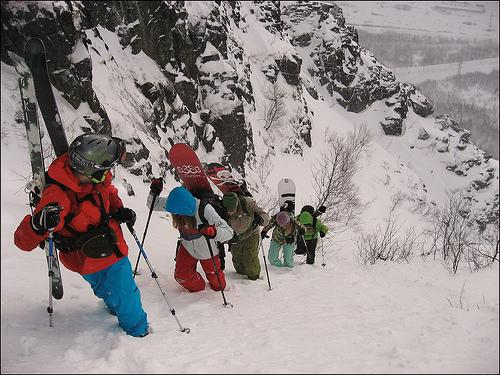Question: why are the wearing gear?
Choices:
A. Protect from injury.
B. Fashion.
C. Protect from cold.
D. Peer pressure.
Answer with the letter. Answer: C Question: where are they?
Choices:
A. Woods.
B. Beach.
C. Mall.
D. Mountain.
Answer with the letter. Answer: D Question: how many people are in this picture?
Choices:
A. Four.
B. Three.
C. Six.
D. Five.
Answer with the letter. Answer: D Question: what are they carrying on their backs?
Choices:
A. Skateboards.
B. Backpacks.
C. Snowboards.
D. Clothing.
Answer with the letter. Answer: C Question: what are the doing?
Choices:
A. Skiing.
B. Climbing.
C. Dancing.
D. Running.
Answer with the letter. Answer: B Question: how many people are looking down?
Choices:
A. Two.
B. Three.
C. One.
D. Four.
Answer with the letter. Answer: C 